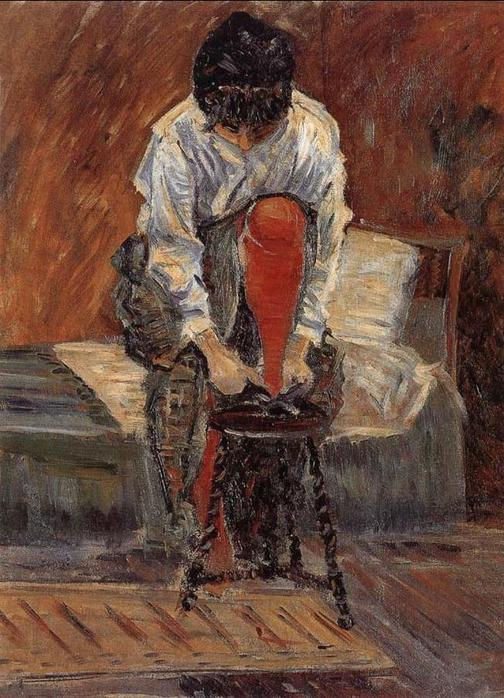Can you discuss the significance of color use in this painting? The color palette in this painting plays a crucial role in conveying mood and character. The warm tones of browns and the striking red of her skirt, contrasting against the muted white of the walls and her blouse, create a vivid but balanced setting. These choices could represent the vibrancy of her inner world versus the simplicity of her surroundings, underscoring the emotional depth and the personal aspect of this Impressionist work. 